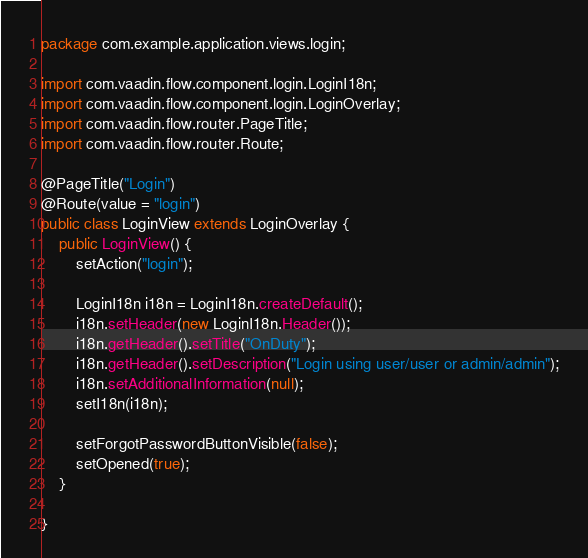<code> <loc_0><loc_0><loc_500><loc_500><_Java_>package com.example.application.views.login;

import com.vaadin.flow.component.login.LoginI18n;
import com.vaadin.flow.component.login.LoginOverlay;
import com.vaadin.flow.router.PageTitle;
import com.vaadin.flow.router.Route;

@PageTitle("Login")
@Route(value = "login")
public class LoginView extends LoginOverlay {
    public LoginView() {
        setAction("login");

        LoginI18n i18n = LoginI18n.createDefault();
        i18n.setHeader(new LoginI18n.Header());
        i18n.getHeader().setTitle("OnDuty");
        i18n.getHeader().setDescription("Login using user/user or admin/admin");
        i18n.setAdditionalInformation(null);
        setI18n(i18n);

        setForgotPasswordButtonVisible(false);
        setOpened(true);
    }

}
</code> 